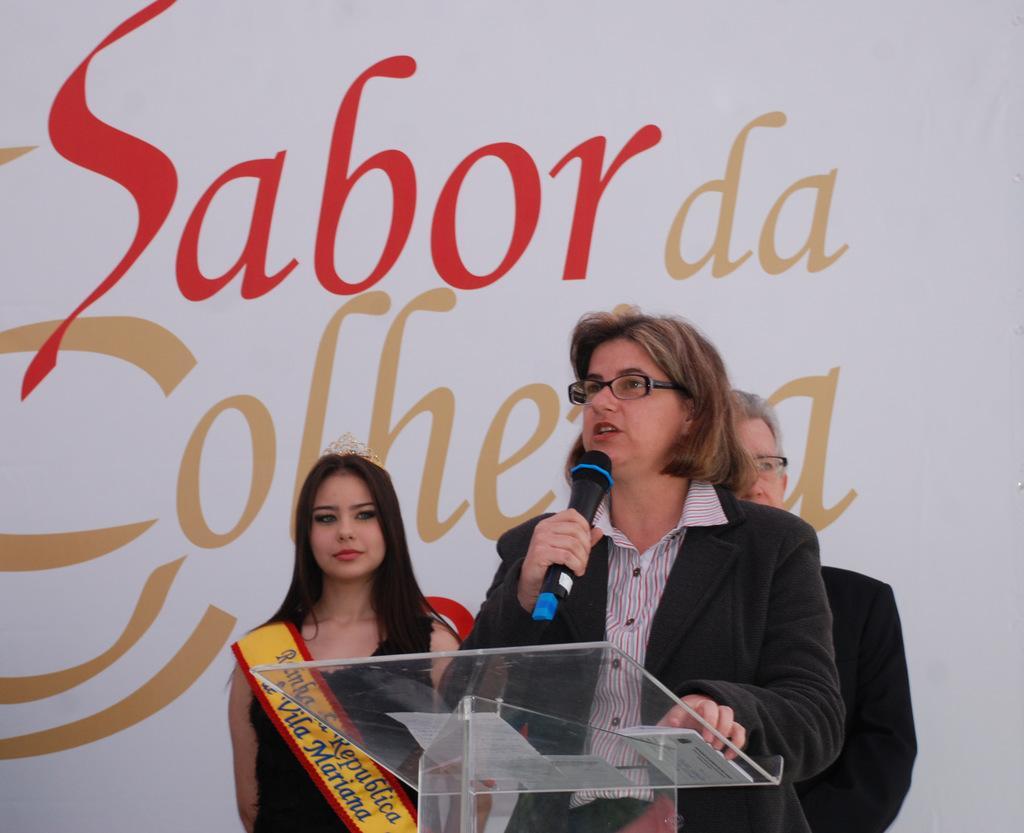Could you give a brief overview of what you see in this image? In this image I can see a woman wearing black blazer and shirt is standing in front of a glass podium and holding a microphone in her hand. In the background I can see two other persons wearing black color dress are standing and the white colored banner. 